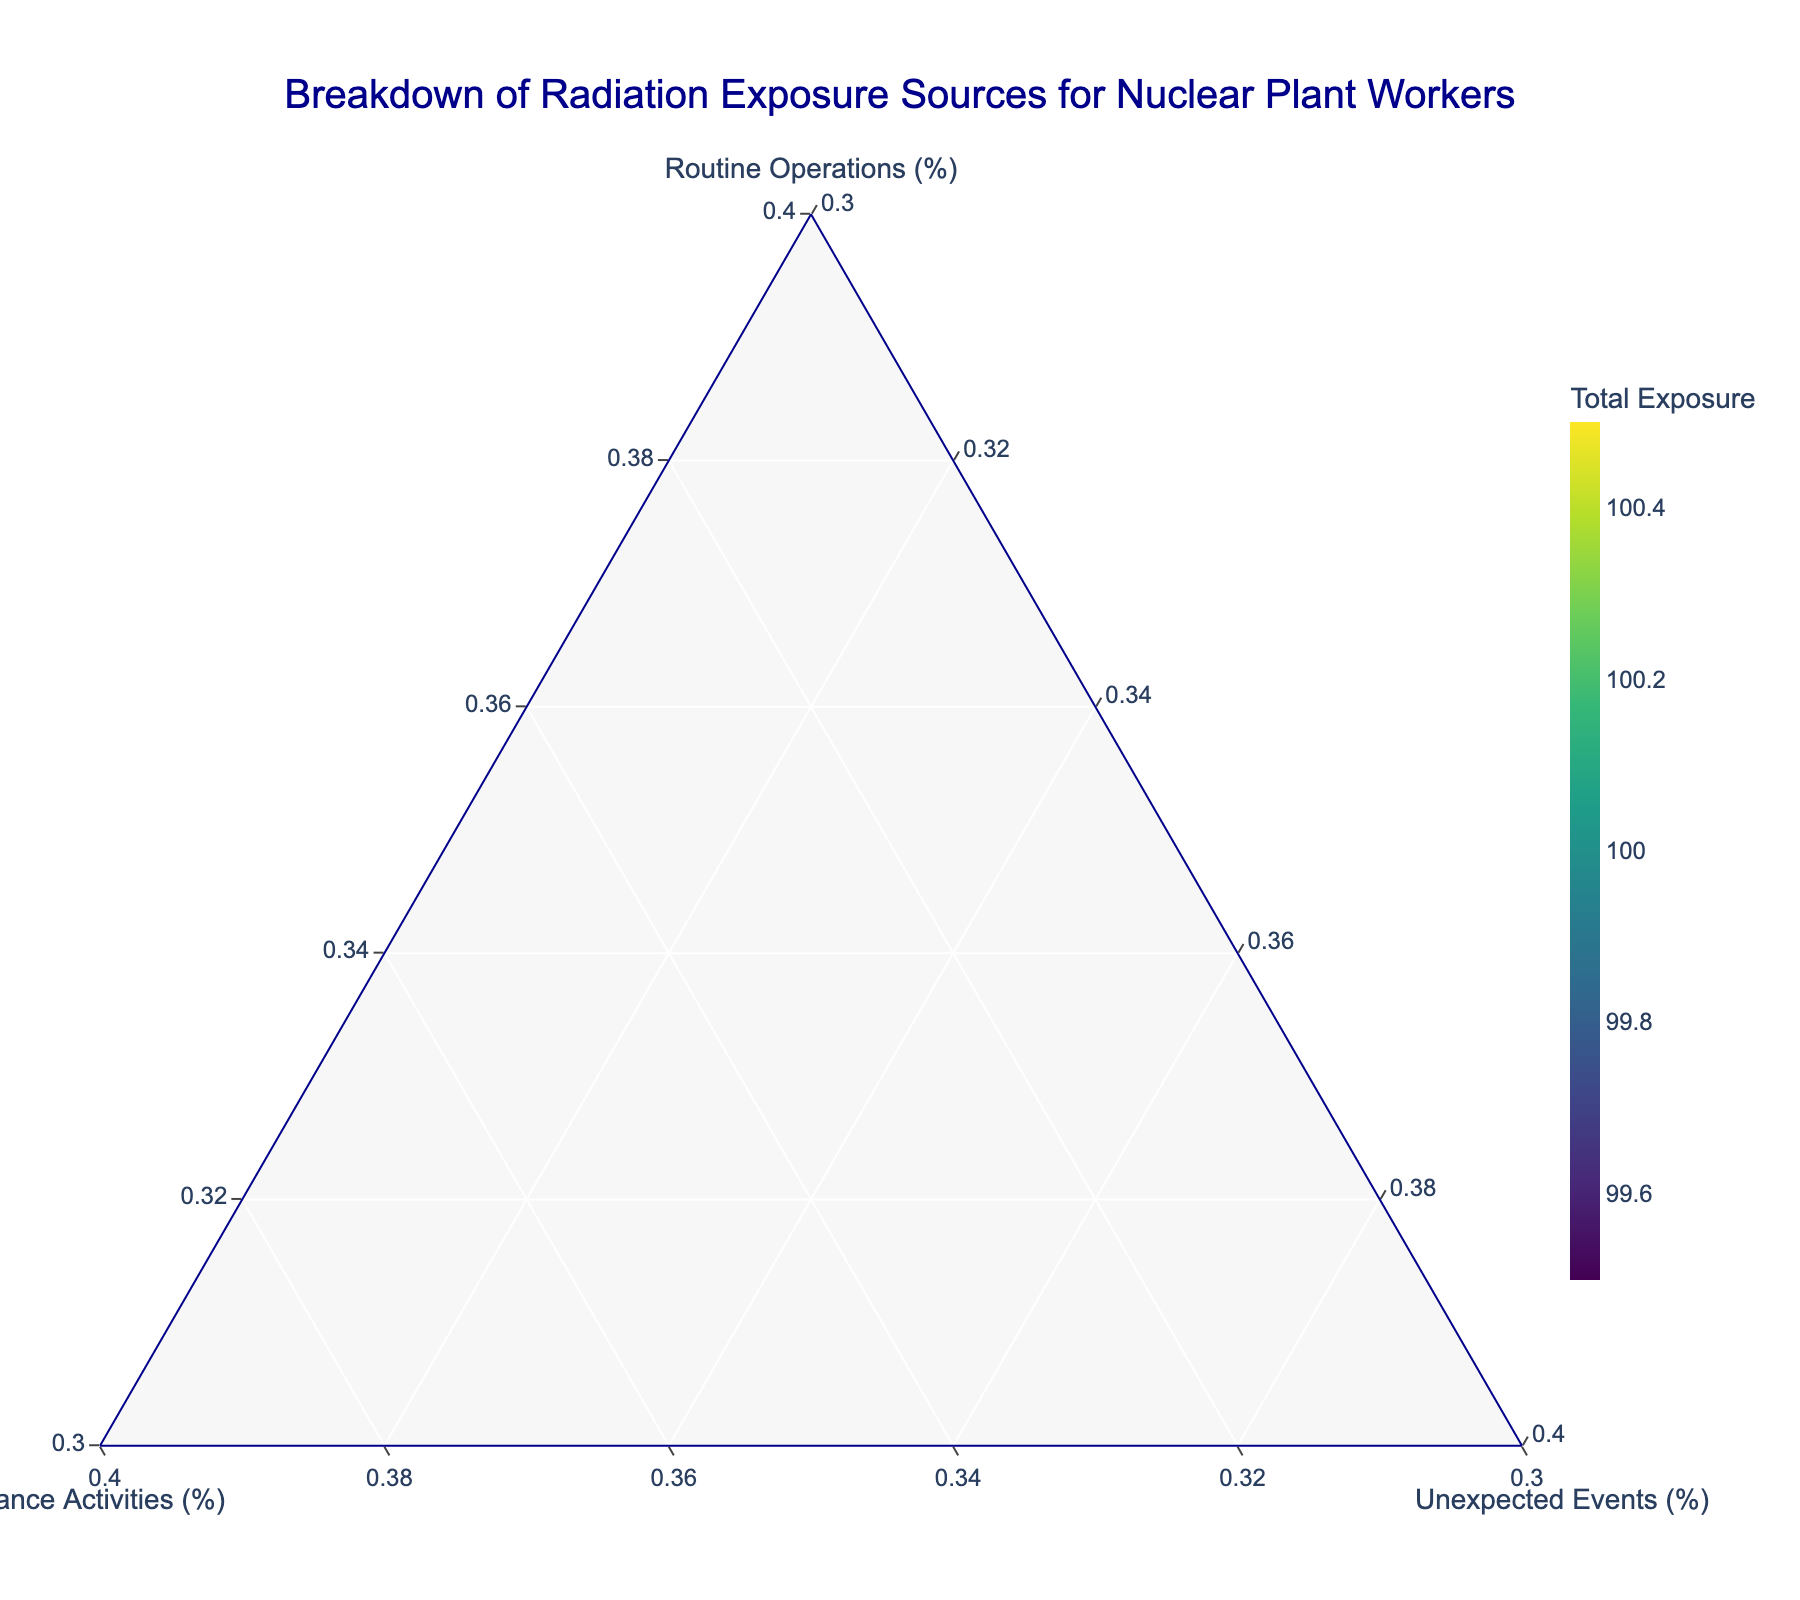What is the title of the plot? The title of the plot can usually be found at the top of the figure. By referring to the top center of the figure, we can see the title: "Breakdown of Radiation Exposure Sources for Nuclear Plant Workers".
Answer: Breakdown of Radiation Exposure Sources for Nuclear Plant Workers How many nuclear plants are represented in the plot? To determine the number of nuclear plants, we count the unique labels or markers on the ternary plot. By counting the text labels, we can identify there are 12 nuclear plants mentioned.
Answer: 12 What is the color scale used for the markers, and what does it represent? The markers on the ternary plot have a color scale based on their total radiation exposure, ranging from lighter to darker shades. The legend or color bar titled "Total Exposure" indicates this.
Answer: Viridis colorscale representing Total Exposure Which nuclear plant has the highest percentage of routine operations exposure? By looking at the axis representing routine operations (%) and finding the marker farthest along the "Routine Operations" axis, we can see that "Brunswick" has the highest percentage.
Answer: Brunswick Which plant has the lowest percentage for maintenance activities? Similarly, by checking the axis for maintenance activities (%) and finding the marker nearest to the baseline for that axis, "Brunswick" has the lowest percentage for maintenance activities.
Answer: Brunswick Compare Diablo Canyon and Susquehanna. Which plant has a higher percentage of exposure from routine operations? By comparing the positions of the markers labeled Diablo Canyon and Susquehanna on the routine operations axis, Diablo Canyon is positioned higher. Therefore, Diablo Canyon has a higher percentage.
Answer: Diablo Canyon Which plants have an equal percentage of exposure from unexpected events? Since the "Unexpected Events" percentage is the same (all are 5%) across the board, all plants have equal exposure from unexpected events.
Answer: All plants Calculate the average percentage of exposure from maintenance activities for all nuclear plants. To find the average, sum up the maintenance activities percentages of all plants and divide by the number of plants. The percentages are 50, 55, 53, 57, 48, 52, 54, 56, 51, 49, 58, 47. Sum = 630, Number of plants = 12, Average = 630 / 12 = 52.5
Answer: 52.5 Compare the total exposures of Diablo Canyon and Fermi. Which plant has a higher total exposure? By referring to the color intensity (Total Exposure) of the markers for Diablo Canyon and Fermi, Fermi has a darker color, indicating a higher total exposure.
Answer: Fermi 